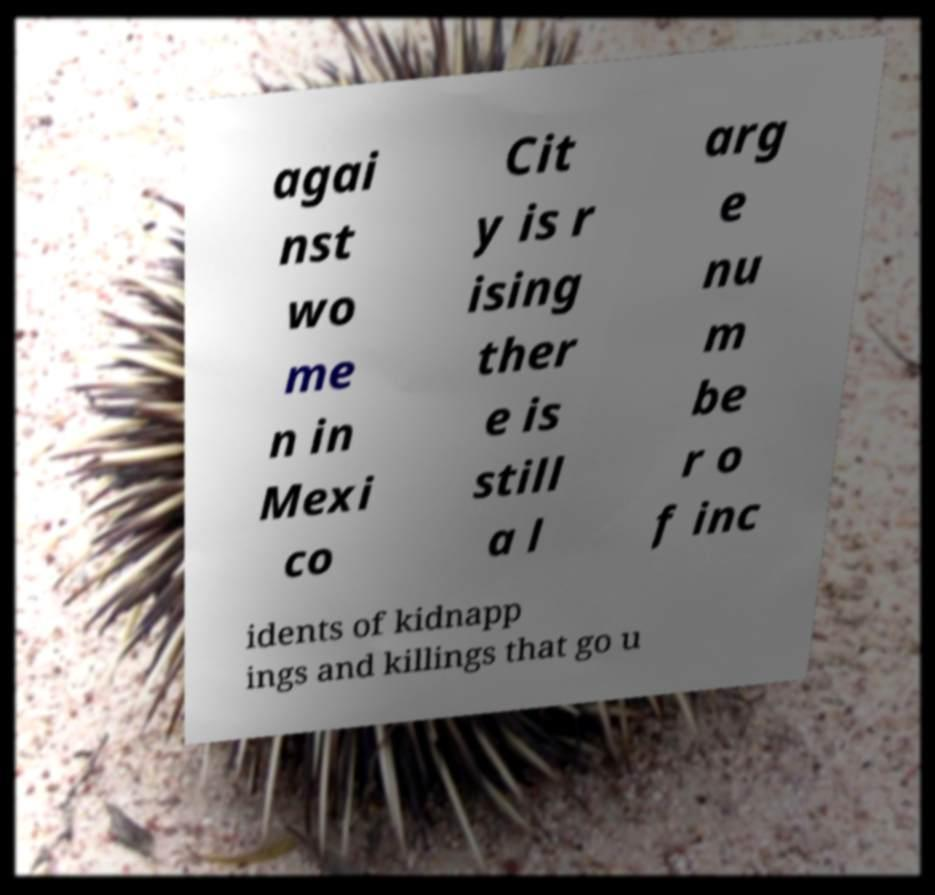For documentation purposes, I need the text within this image transcribed. Could you provide that? agai nst wo me n in Mexi co Cit y is r ising ther e is still a l arg e nu m be r o f inc idents of kidnapp ings and killings that go u 